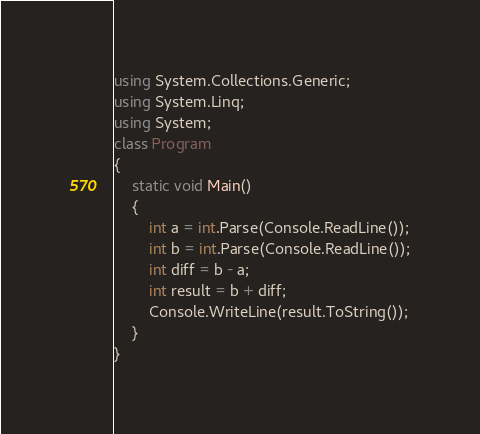<code> <loc_0><loc_0><loc_500><loc_500><_C#_>using System.Collections.Generic;
using System.Linq;
using System;
class Program
{
    static void Main()
    {
        int a = int.Parse(Console.ReadLine());
        int b = int.Parse(Console.ReadLine());
        int diff = b - a;
        int result = b + diff;
        Console.WriteLine(result.ToString());
    }
}</code> 